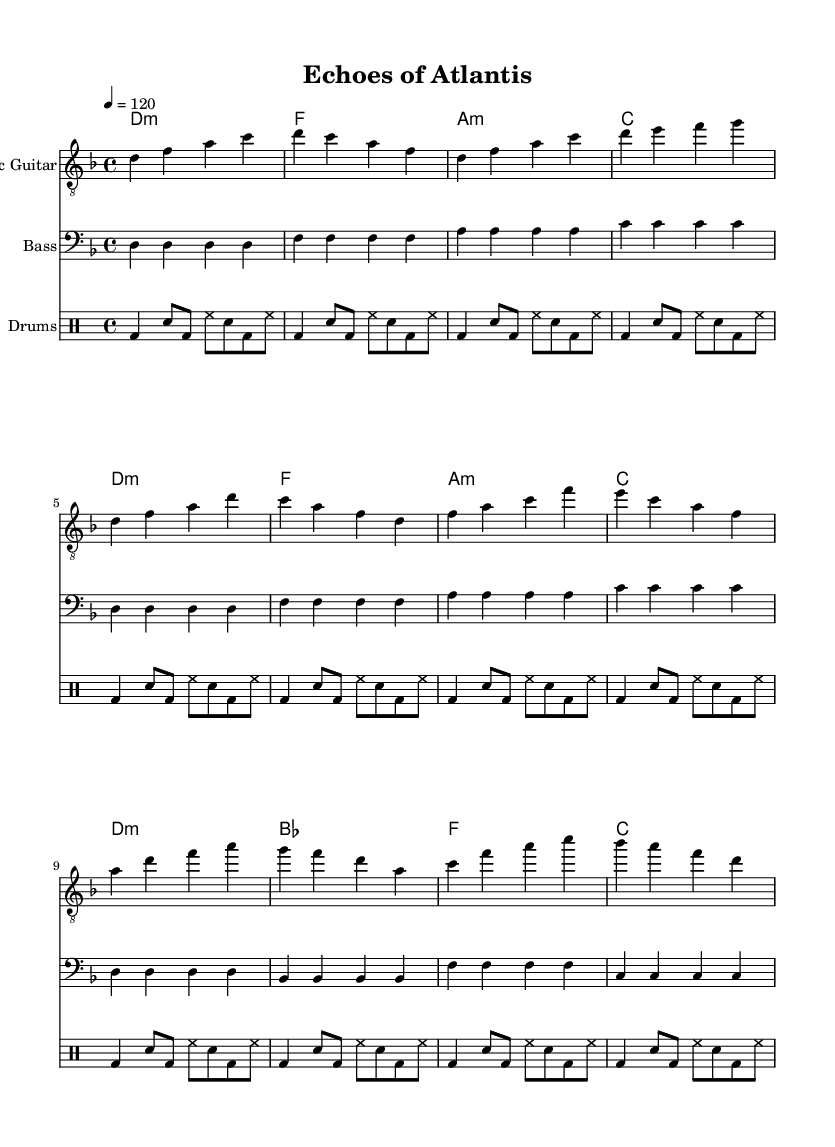What is the key signature of this music? The key signature is indicated by the presence of one flat note that applies to the entire piece. In this sheet music, the key signature is D minor, which indicates the use of one flat, B flat.
Answer: D minor What is the time signature of this music? The time signature is found at the beginning of the sheet music. In this piece, the time signature is 4/4, which means there are four beats in each measure and the quarter note gets one beat.
Answer: 4/4 What is the tempo marking for this piece? The tempo is presented as "4 = 120," which indicates that there are 120 beats per minute, and the quarter note is the beat unit.
Answer: 120 How many measures are in the electric guitar part? To find the number of measures, we count the sets of vertical lines, which indicate the end of each measure. There are 8 measures in total within the electric guitar part.
Answer: 8 Which instrument has a bass clef? The instrument using the bass clef is indicated at the beginning of its staff. In this sheet music, the bass guitar part is the only one using the bass clef, which is typically used for lower-pitched instruments.
Answer: Bass Guitar What is the first chord in the chords part? The first chord is noted directly at the beginning of the chords section. Here, it is specifically labeled as D minor, indicating the tonality and root of the chord playing during the first measure.
Answer: D minor 